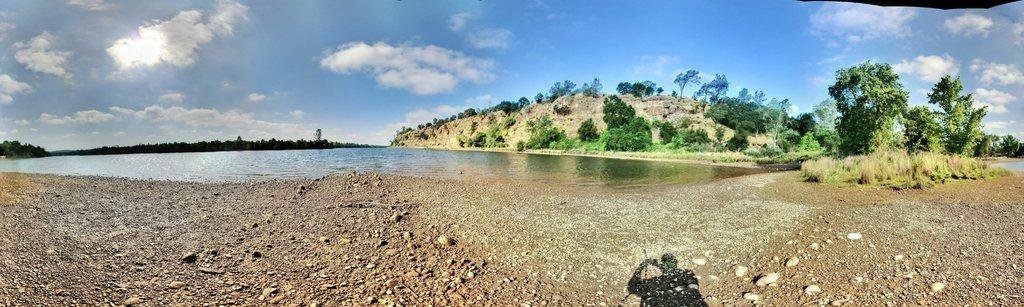What type of natural environment is depicted in the image? The image features trees, water, and a mountain, indicating a natural environment. What can be seen in the sky in the image? The sky is visible in the image. What is the terrain like in the image? The image includes water and a mountain, suggesting a varied terrain. What is present at the bottom of the image? There is a shadow of a person and stones at the bottom of the image. What statement does the lumber make in the image? There is no lumber present in the image, so it cannot make any statements. 